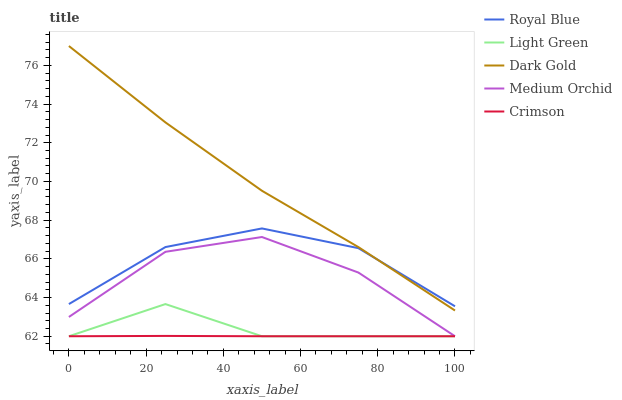Does Crimson have the minimum area under the curve?
Answer yes or no. Yes. Does Dark Gold have the maximum area under the curve?
Answer yes or no. Yes. Does Royal Blue have the minimum area under the curve?
Answer yes or no. No. Does Royal Blue have the maximum area under the curve?
Answer yes or no. No. Is Crimson the smoothest?
Answer yes or no. Yes. Is Medium Orchid the roughest?
Answer yes or no. Yes. Is Royal Blue the smoothest?
Answer yes or no. No. Is Royal Blue the roughest?
Answer yes or no. No. Does Royal Blue have the lowest value?
Answer yes or no. No. Does Royal Blue have the highest value?
Answer yes or no. No. Is Medium Orchid less than Royal Blue?
Answer yes or no. Yes. Is Royal Blue greater than Crimson?
Answer yes or no. Yes. Does Medium Orchid intersect Royal Blue?
Answer yes or no. No. 